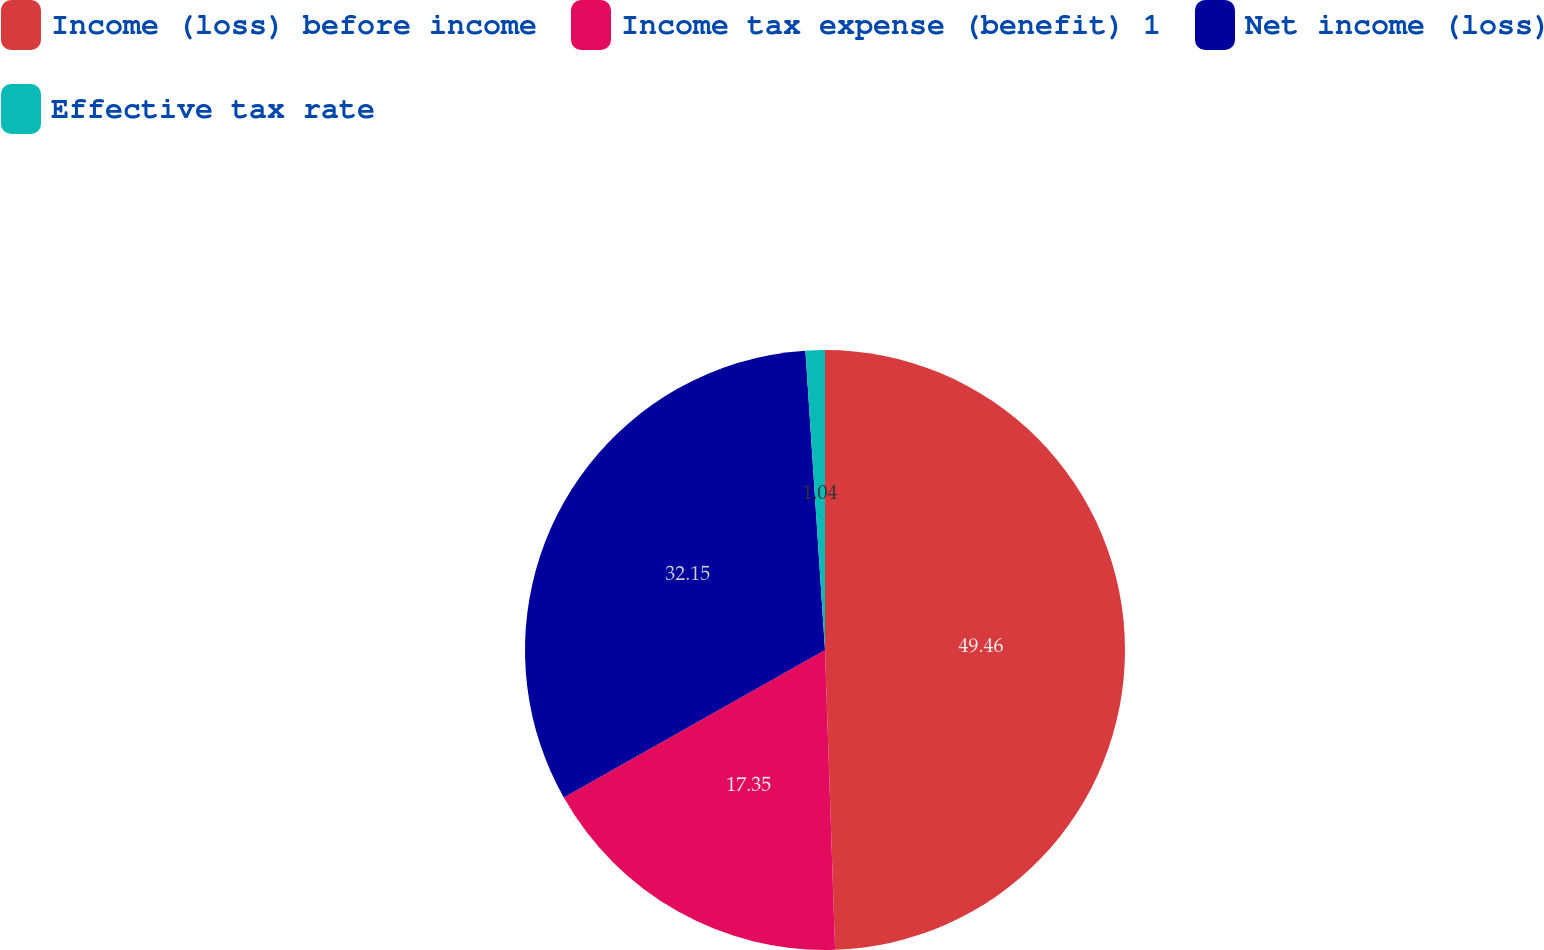<chart> <loc_0><loc_0><loc_500><loc_500><pie_chart><fcel>Income (loss) before income<fcel>Income tax expense (benefit) 1<fcel>Net income (loss)<fcel>Effective tax rate<nl><fcel>49.47%<fcel>17.35%<fcel>32.15%<fcel>1.04%<nl></chart> 